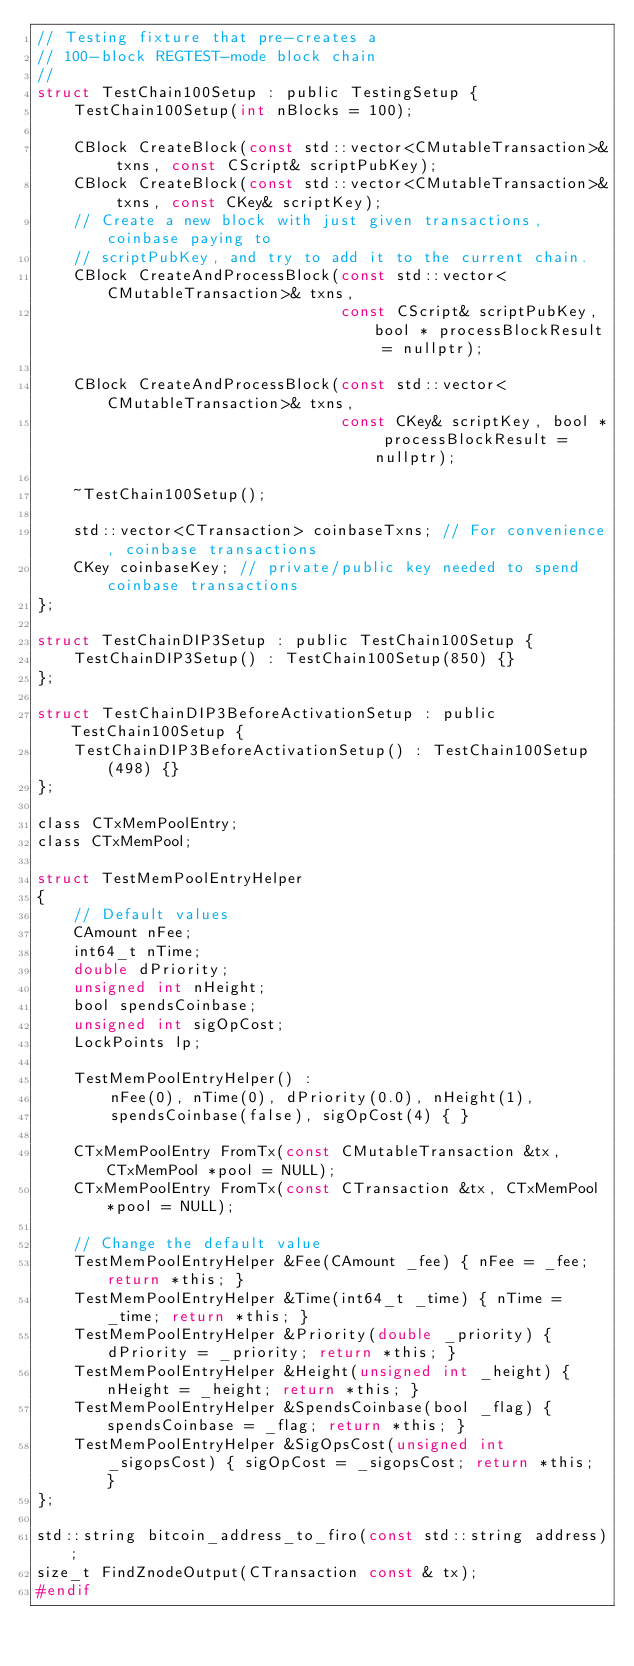<code> <loc_0><loc_0><loc_500><loc_500><_C_>// Testing fixture that pre-creates a
// 100-block REGTEST-mode block chain
//
struct TestChain100Setup : public TestingSetup {
    TestChain100Setup(int nBlocks = 100);

    CBlock CreateBlock(const std::vector<CMutableTransaction>& txns, const CScript& scriptPubKey);
    CBlock CreateBlock(const std::vector<CMutableTransaction>& txns, const CKey& scriptKey);
    // Create a new block with just given transactions, coinbase paying to
    // scriptPubKey, and try to add it to the current chain.
    CBlock CreateAndProcessBlock(const std::vector<CMutableTransaction>& txns,
                                 const CScript& scriptPubKey, bool * processBlockResult = nullptr);

    CBlock CreateAndProcessBlock(const std::vector<CMutableTransaction>& txns,
                                 const CKey& scriptKey, bool * processBlockResult = nullptr);

    ~TestChain100Setup();

    std::vector<CTransaction> coinbaseTxns; // For convenience, coinbase transactions
    CKey coinbaseKey; // private/public key needed to spend coinbase transactions
};

struct TestChainDIP3Setup : public TestChain100Setup {
    TestChainDIP3Setup() : TestChain100Setup(850) {}
};

struct TestChainDIP3BeforeActivationSetup : public TestChain100Setup {
    TestChainDIP3BeforeActivationSetup() : TestChain100Setup(498) {}
};

class CTxMemPoolEntry;
class CTxMemPool;

struct TestMemPoolEntryHelper
{
    // Default values
    CAmount nFee;
    int64_t nTime;
    double dPriority;
    unsigned int nHeight;
    bool spendsCoinbase;
    unsigned int sigOpCost;
    LockPoints lp;

    TestMemPoolEntryHelper() :
        nFee(0), nTime(0), dPriority(0.0), nHeight(1),
        spendsCoinbase(false), sigOpCost(4) { }

    CTxMemPoolEntry FromTx(const CMutableTransaction &tx, CTxMemPool *pool = NULL);
    CTxMemPoolEntry FromTx(const CTransaction &tx, CTxMemPool *pool = NULL);

    // Change the default value
    TestMemPoolEntryHelper &Fee(CAmount _fee) { nFee = _fee; return *this; }
    TestMemPoolEntryHelper &Time(int64_t _time) { nTime = _time; return *this; }
    TestMemPoolEntryHelper &Priority(double _priority) { dPriority = _priority; return *this; }
    TestMemPoolEntryHelper &Height(unsigned int _height) { nHeight = _height; return *this; }
    TestMemPoolEntryHelper &SpendsCoinbase(bool _flag) { spendsCoinbase = _flag; return *this; }
    TestMemPoolEntryHelper &SigOpsCost(unsigned int _sigopsCost) { sigOpCost = _sigopsCost; return *this; }
};

std::string bitcoin_address_to_firo(const std::string address);
size_t FindZnodeOutput(CTransaction const & tx);
#endif
</code> 